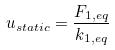Convert formula to latex. <formula><loc_0><loc_0><loc_500><loc_500>u _ { s t a t i c } = \frac { F _ { 1 , e q } } { k _ { 1 , e q } }</formula> 